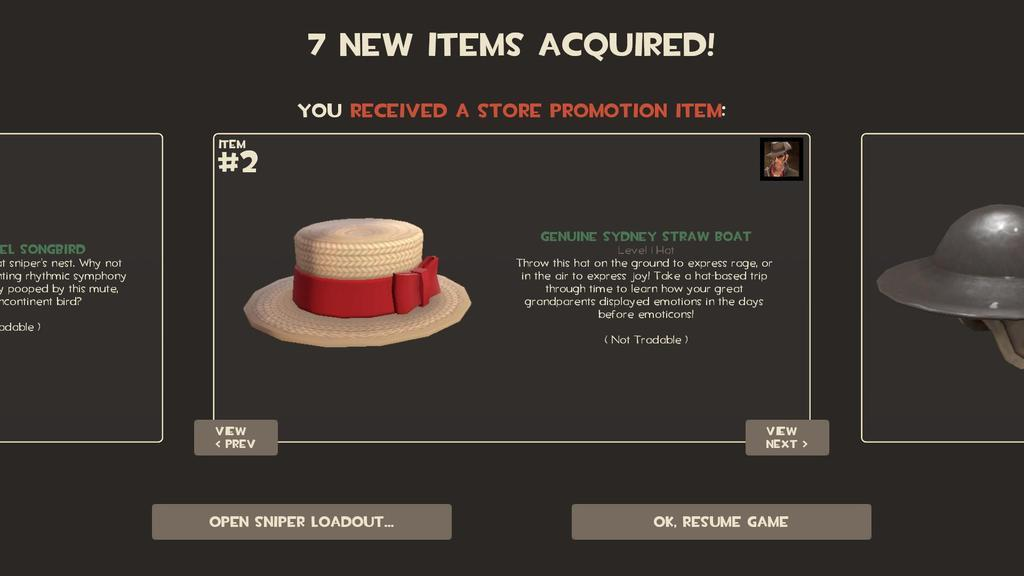What is the main subject of focus of the image? The main focus of the image is a depiction of hats. Are there any words or letters in the image? Yes, there is writing in the image. What color is the background of the image? The background of the image is black. What type of joke can be seen in the image? There is no joke present in the image. 